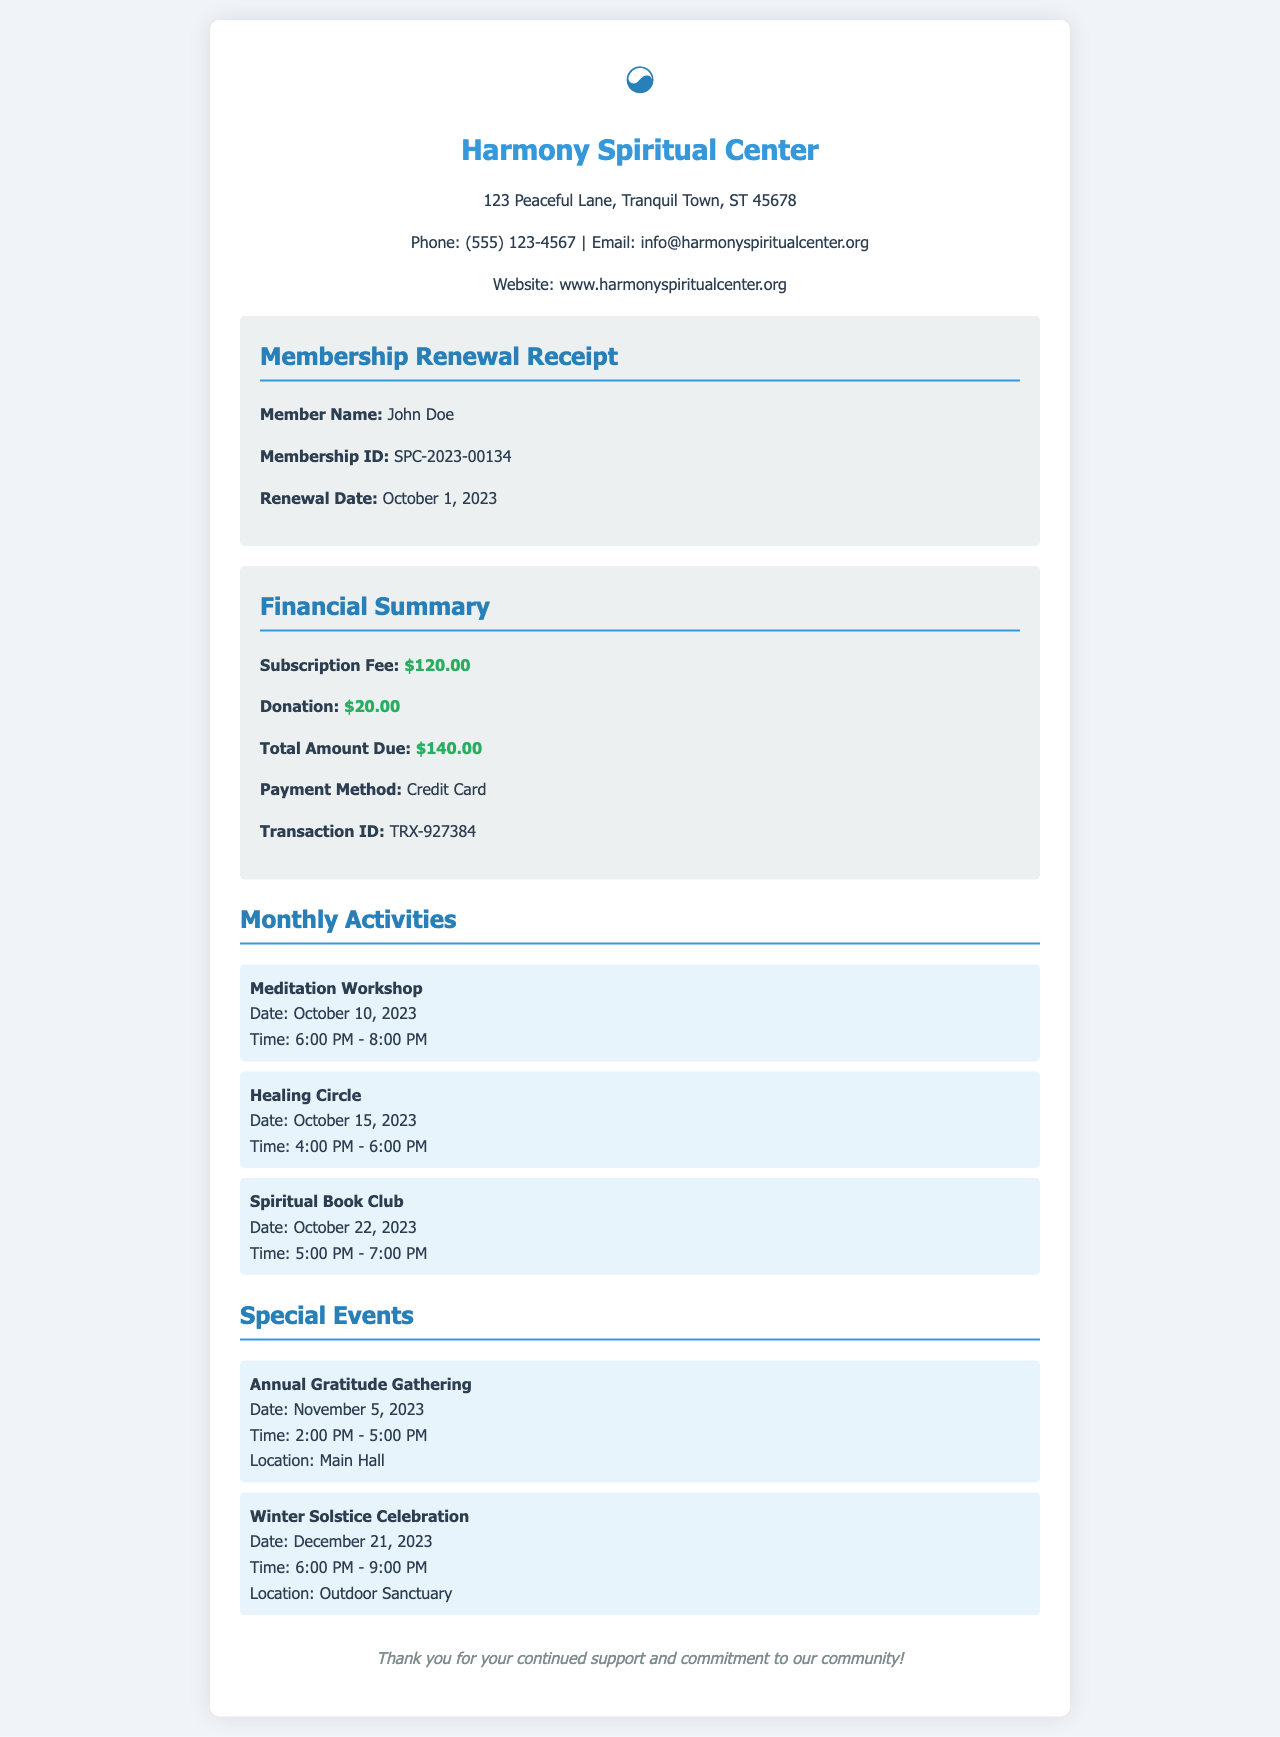What is the member's name? The member's name is listed in the member details section of the document.
Answer: John Doe What is the renewal date? The renewal date is stated in the member details section of the document.
Answer: October 1, 2023 What is the total amount due? The total amount due is found in the financial summary section of the document.
Answer: $140.00 When is the Meditation Workshop? The date and time of the Meditation Workshop are listed under monthly activities.
Answer: October 10, 2023, 6:00 PM - 8:00 PM What location is the Winter Solstice Celebration held? The location is mentioned in the special events section of the document.
Answer: Outdoor Sanctuary What is the donation amount? The donation amount is included in the financial summary section of the document.
Answer: $20.00 How many monthly activities are listed? The number of monthly activities can be counted from the activities section of the document.
Answer: Three What is the transaction ID? The transaction ID is mentioned in the financial summary section of the document.
Answer: TRX-927384 What is the date of the Annual Gratitude Gathering? The date of the Annual Gratitude Gathering is provided in the special events section.
Answer: November 5, 2023 